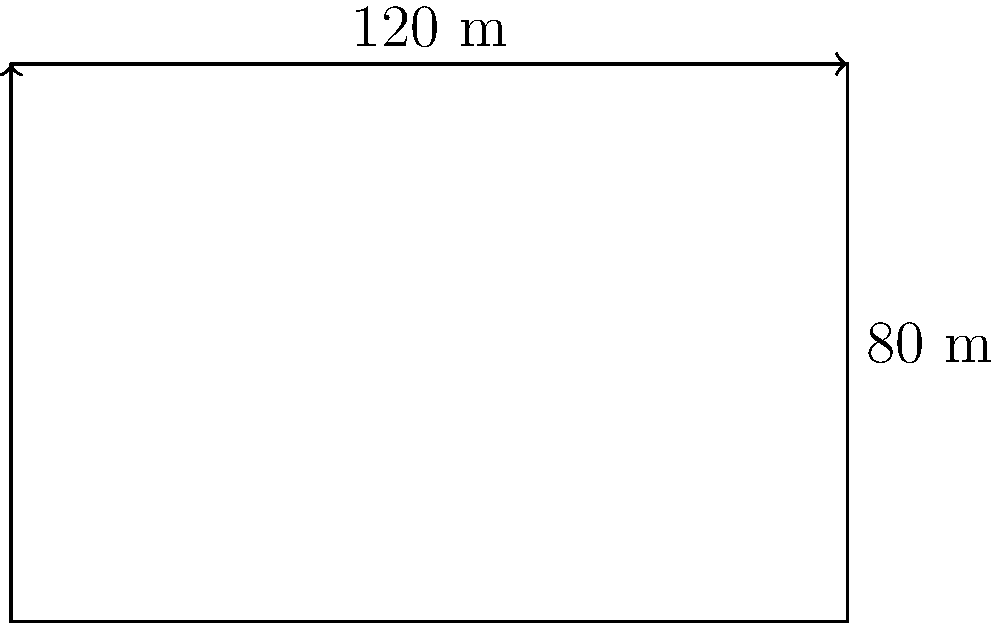A guest asks about the total distance around the hotel property. Given that the hotel's rectangular grounds measure 120 meters in length and 80 meters in width, what would you tell them about the perimeter of the property? To find the perimeter of the rectangular hotel property, we need to follow these steps:

1. Identify the formula for the perimeter of a rectangle:
   Perimeter = 2 × (length + width)

2. Substitute the given dimensions:
   Length = 120 meters
   Width = 80 meters

3. Apply the formula:
   Perimeter = 2 × (120 m + 80 m)
             = 2 × 200 m
             = 400 m

Therefore, the total distance around the hotel property (perimeter) is 400 meters.
Answer: 400 meters 